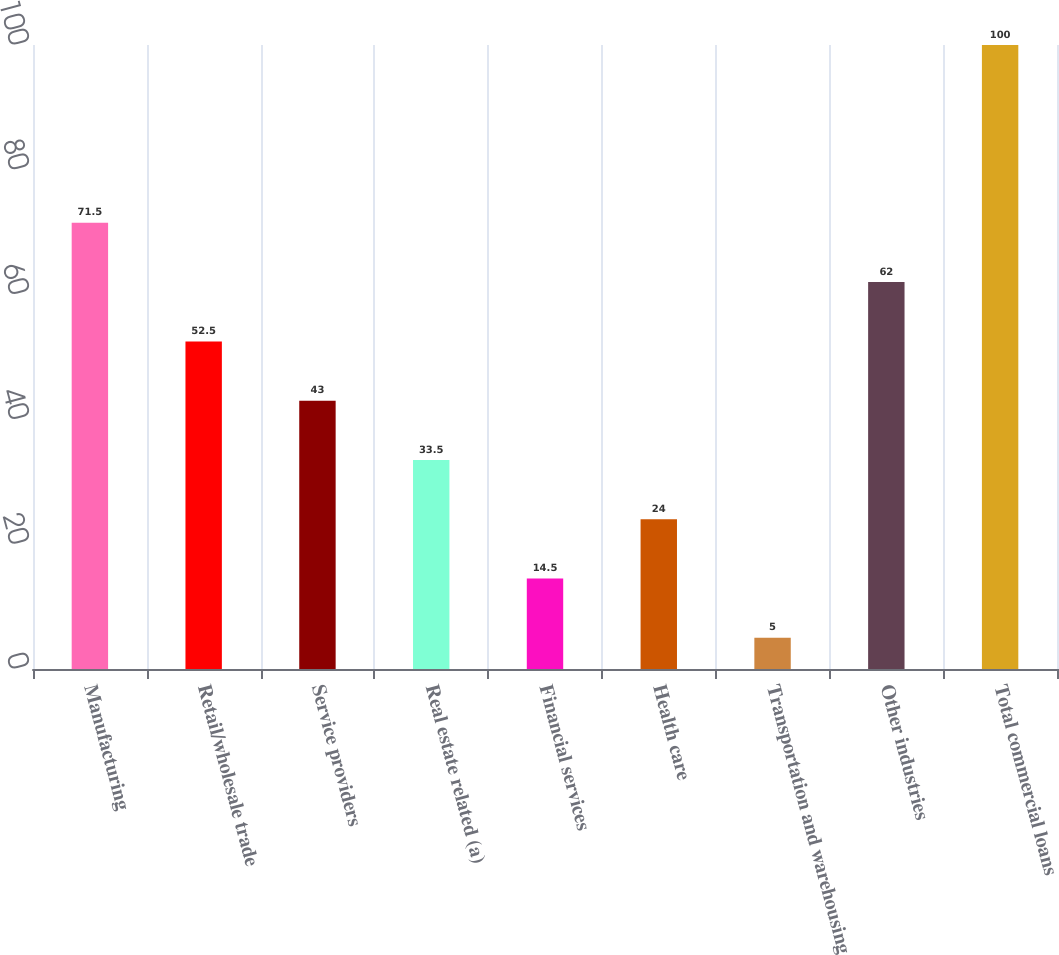Convert chart. <chart><loc_0><loc_0><loc_500><loc_500><bar_chart><fcel>Manufacturing<fcel>Retail/wholesale trade<fcel>Service providers<fcel>Real estate related (a)<fcel>Financial services<fcel>Health care<fcel>Transportation and warehousing<fcel>Other industries<fcel>Total commercial loans<nl><fcel>71.5<fcel>52.5<fcel>43<fcel>33.5<fcel>14.5<fcel>24<fcel>5<fcel>62<fcel>100<nl></chart> 